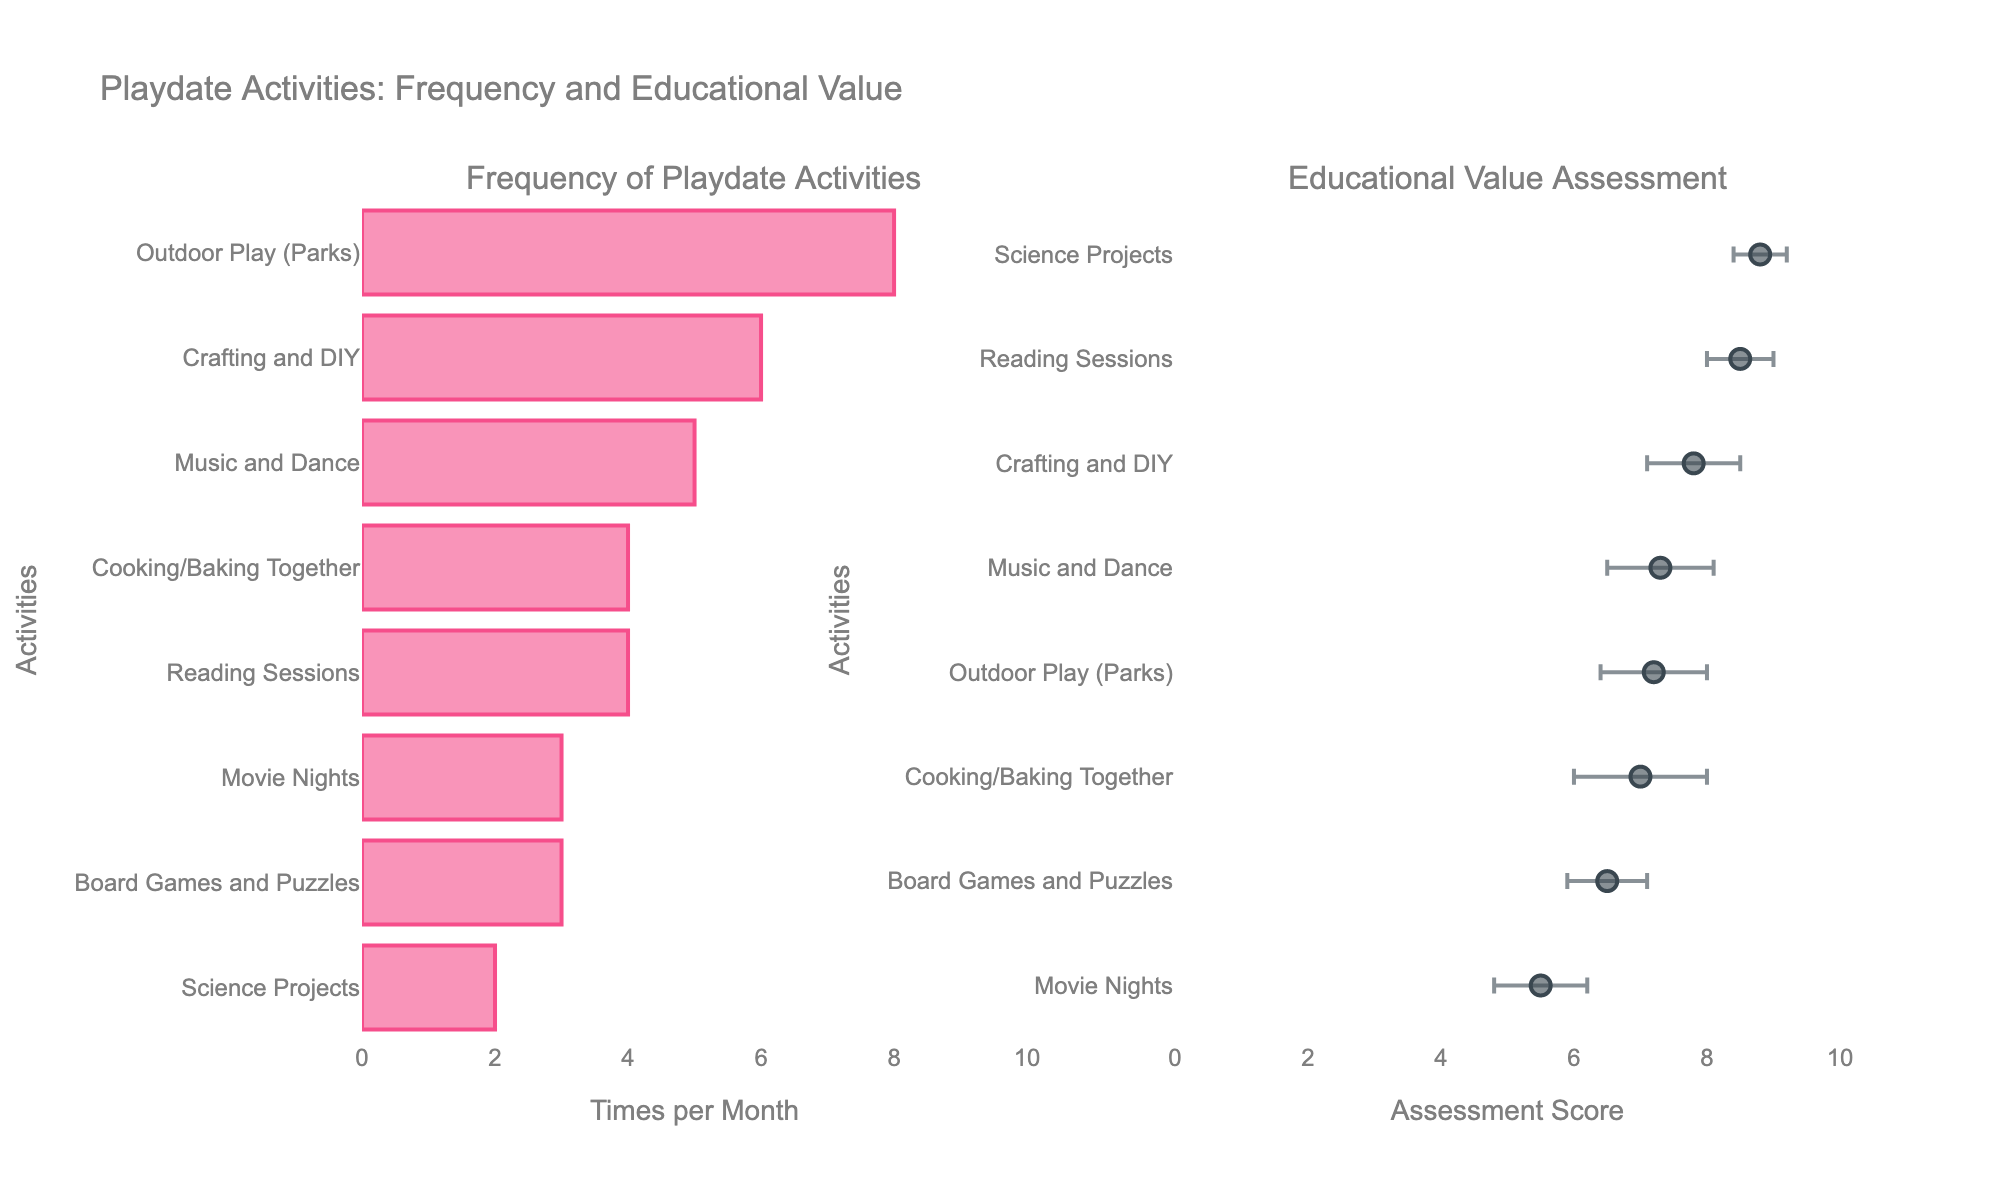What is the title of the figure? The title is displayed at the top of the figure.
Answer: Playdate Activities: Frequency and Educational Value Which activity has the highest frequency of playdates per month? Refer to the bar chart on the left subplot. The activity with the longest bar is Outdoor Play (Parks).
Answer: Outdoor Play (Parks) Which activity has the lowest educational assessment score based on parental assessment? Check the right subplot with error bars. The activity with the lowest average assessment score is at the bottom of the list.
Answer: Movie Nights How many activities have a frequency of 4 playdates per month? Identify the activities with bars extending to 4 on the left subplot. There are two such activities.
Answer: 2 What is the average frequency per month of Board Games and Puzzles and Movie Nights? Refer to the left subplot to find their frequencies. Add them and divide by 2: (3 + 3) / 2.
Answer: 3 Which activity has the smallest error bar in the educational assessment subplot? Check the right subplot. The smallest error bar corresponds to Science Projects.
Answer: Science Projects Do any activities have the same frequency per month? If so, which ones? Look for activities that have bars extending to the same value on the left subplot. "Reading Sessions" and "Cooking/Baking Together" both have 4 playdates per month.
Answer: Reading Sessions, Cooking/Baking Together Which activity is both assessed as highly educational and has a relatively high frequency of playdates? Look for activities in the right subplot with high average assessment scores and check their frequency in the left subplot. Science Projects have a high assessment score and comparatively frequent playdates.
Answer: Science Projects Which activity has an educational assessment score closest to 8? Find the data points on the right subplot closest to the 8 mark on the x-axis. Reading Sessions have an average assessment of 8.5, which is closest to 8.
Answer: Reading Sessions Calculate the difference in frequency per month between Outdoor Play (Parks) and Board Games and Puzzles. Find their frequencies on the left subplot and subtract: 8 - 3.
Answer: 5 